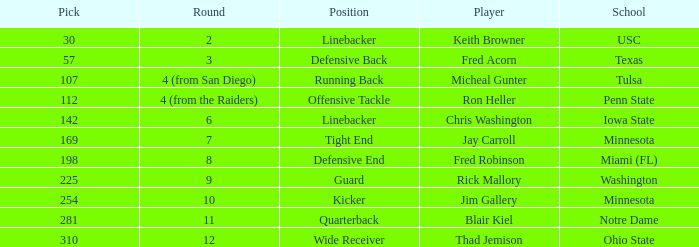What is the pick number of Penn State? 112.0. 